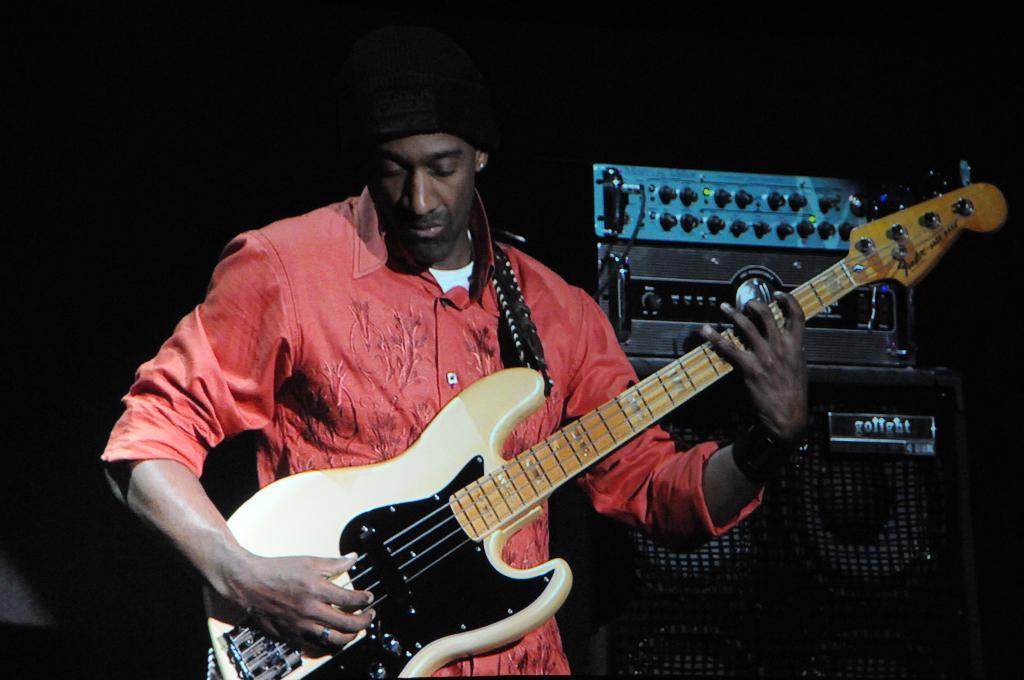How would you summarize this image in a sentence or two? In this image I can see the person playing the musical instrument. To the right I can see an electronic device. I can see the black background. 